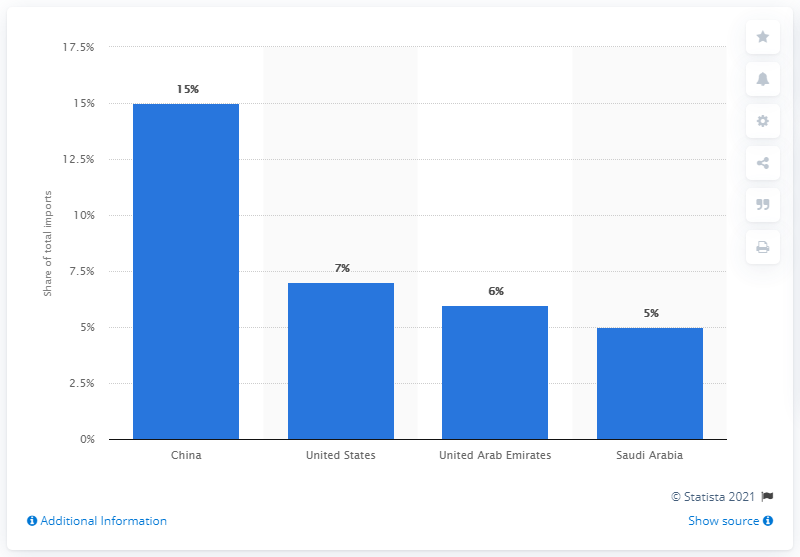Draw attention to some important aspects in this diagram. In 2019, India's main import partner was China. 